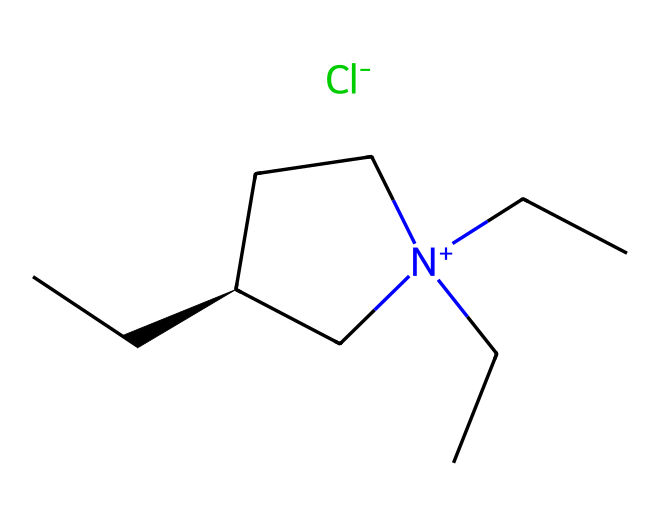What is the overall charge of this ionic liquid? The structure includes a positively charged nitrogen atom ([N+]) and a negatively charged chloride ion ([Cl-]), making the overall charge neutral since positive and negative charges balance each other.
Answer: neutral How many carbon atoms are present in the structure? By counting each carbon atom in the structure, we find a total of 9 carbon atoms present in the molecule.
Answer: 9 What functional group is represented by the nitrogen atom in the structure? The nitrogen atom that carries a positive charge indicates it is part of a quaternary ammonium functional group, which is typical in ionic liquids.
Answer: quaternary ammonium Which part of the structure contributes to its high thermal stability? The presence of multiple alkyl chains attached to the nitrogen enhances the thermal stability of the ionic liquid due to steric hindrance and reduced volatility.
Answer: alkyl chains What does the presence of the chloride ion indicate about the solvent properties? The chloride ion being the anion suggests that this ionic liquid can dissolve a wide range of polar and nonpolar compounds, giving it good solvent properties.
Answer: good solvent How many hydrogen atoms are there in this ionic liquid composition? After examining the structure, we count a total of 19 hydrogen atoms connected to the carbon and nitrogen atoms.
Answer: 19 